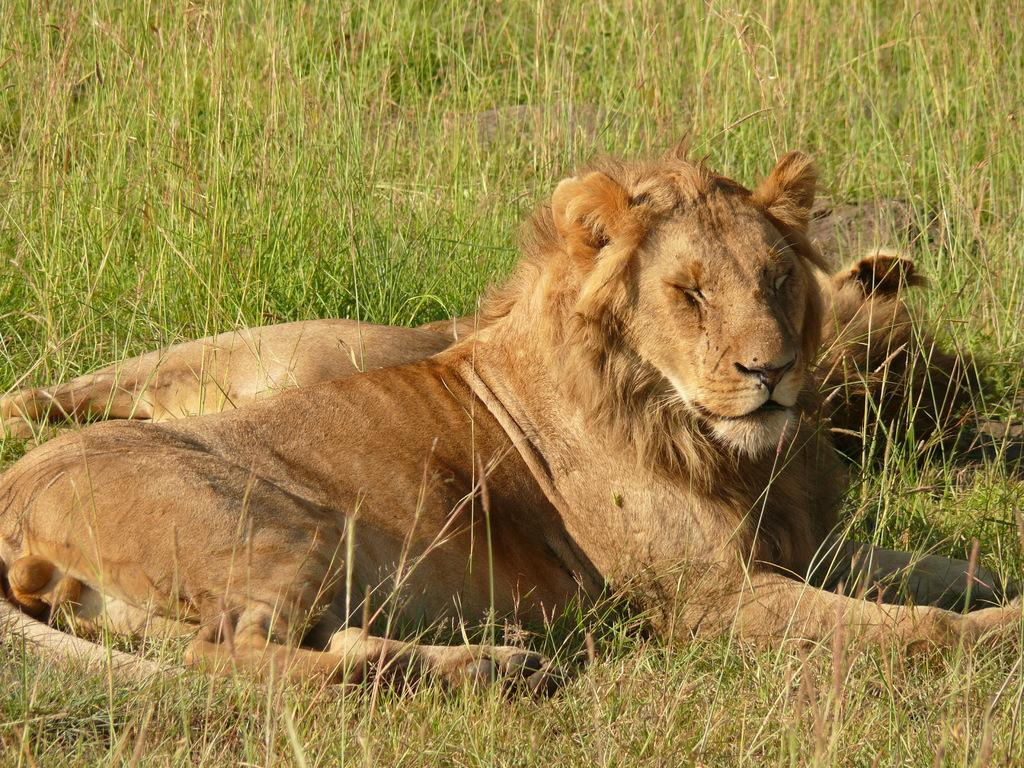How many animals are present in the image? There are two animals in the image. What are the animals doing in the image? The animals are sitting on the grassland. What type of low planes can be seen flying over the table in the image? There is no table or planes present in the image; it features two animals sitting on the grassland. 